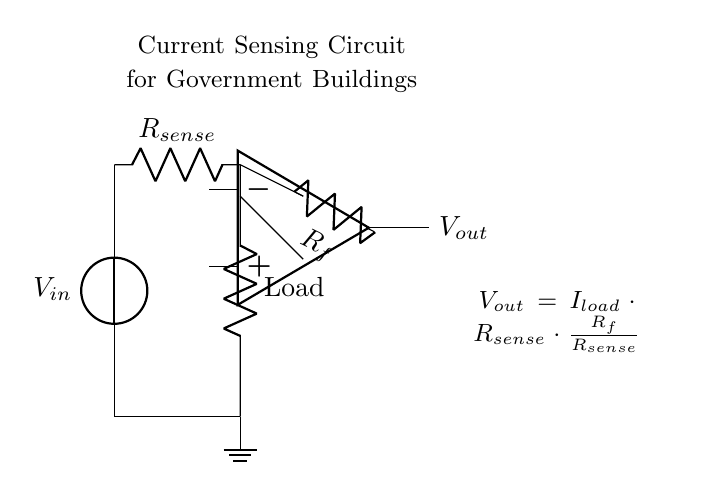What is the input voltage of this circuit? The input voltage is represented by the voltage source labeled V_in at the top left of the diagram. It shows the source providing voltage to the circuit.
Answer: V_in What does the resistor R_sense do? The resistor R_sense, labeled in the circuit, is used for current sensing. It measures the current passing through it, which helps to monitor the power consumption in the load.
Answer: Current sensing What is the function of the operational amplifier? The operational amplifier, shown in the circuit, amplifies the voltage difference created across the R_sense resistor, which allows for easy monitoring and measurement of the current in the load.
Answer: Voltage amplification What is the relationship between V_out and I_load? The output voltage V_out is proportional to I_load (the load current), R_sense, and R_f (feedback resistor) as indicated by the equation in the diagram, illustrating how the output relates to the load current through the resistor values.
Answer: V_out = I_load * R_sense * (R_f / R_sense) How is the load connected in this circuit? The load is connected in parallel to R_sense, indicating that the load directly receives power from V_in while also allowing the current to be measured through R_sense for monitoring.
Answer: In parallel What happens if the resistance R_f is increased? Increasing the resistance R_f will amplify the output voltage V_out, thus making it more sensitive to changes in the load current I_load, allowing for finer monitoring of power consumption.
Answer: Increases V_out Which component is used to provide a reference point in the circuit? The ground symbol at the bottom of the circuit provides a reference point, ensuring that all voltages in the circuit are measured with respect to this common ground.
Answer: Ground 